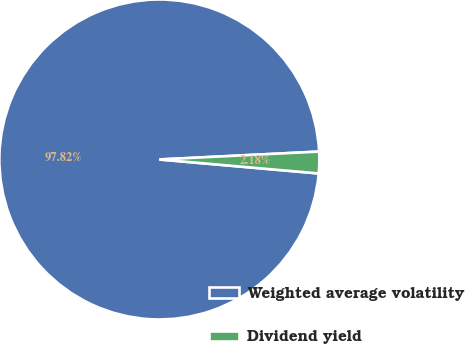Convert chart to OTSL. <chart><loc_0><loc_0><loc_500><loc_500><pie_chart><fcel>Weighted average volatility<fcel>Dividend yield<nl><fcel>97.82%<fcel>2.18%<nl></chart> 